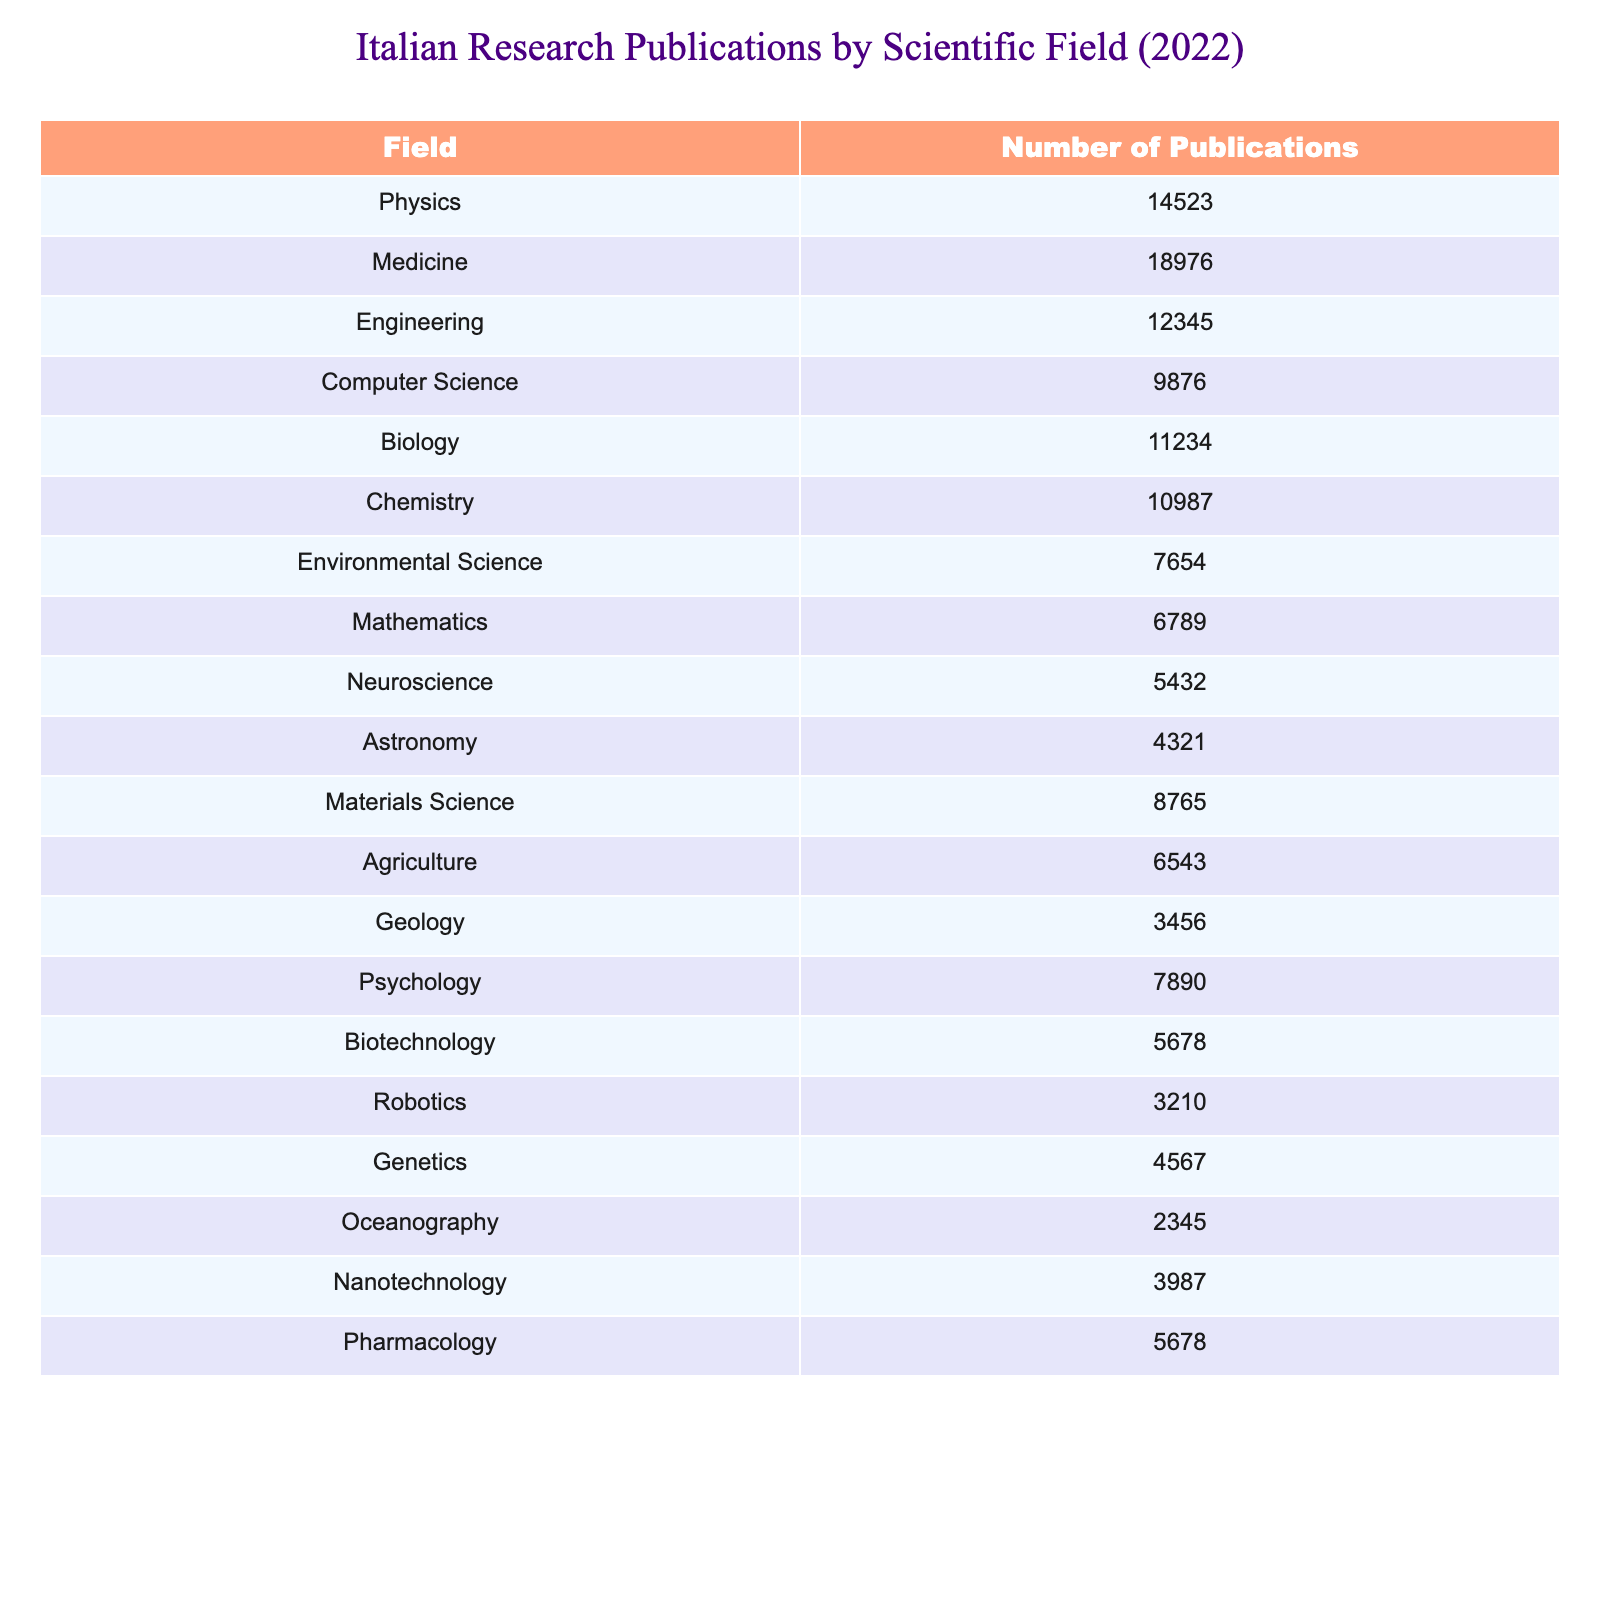What is the field with the highest number of research publications? By examining the table, it's clear that "Medicine" has the highest number of publications at 18976.
Answer: Medicine How many research publications were there in Chemistry? The table indicates that the number of publications in Chemistry is 10987.
Answer: 10987 What is the total number of publications in Physics and Engineering combined? Adding the values from the table, Physics has 14523 and Engineering has 12345, so 14523 + 12345 = 26868.
Answer: 26868 Is the number of publications in Biology greater than in Physics? The table shows that Biology has 11234 publications, which is less than Physics at 14523, so the answer is no.
Answer: No Which two fields have the least number of publications? By reviewing the table, "Oceanography" with 2345 publications and "Robotics" with 3210 publications represent the lowest counts.
Answer: Oceanography and Robotics What is the average number of publications across all fields listed? There are 20 fields, and the total number of publications is the sum of all listed values: 14523 + 18976 + 12345 + 9876 + 11234 + 10987 + 7654 + 6789 + 5432 + 4321 + 8765 + 6543 + 3456 + 7890 + 5678 + 3210 + 4567 + 2345 + 3987 + 5678 = 100,968. Dividing this by 20 gives an average of 5048.4.
Answer: Approximately 5048.4 How much greater is the publication count in Medicine compared to Neuroscience? Medicine has 18976 publications versus Neuroscience's 5432. Calculating the difference yields 18976 - 5432 = 13544.
Answer: 13544 Are there more publications in Environmental Science than in Agriculture? The table shows Environmental Science has 7654 publications and Agriculture has 6543. Since 7654 is greater than 6543, the answer is yes.
Answer: Yes What percentage of the total publications do Computer Science publications represent? The total publications across all fields are 100,968, with Computer Science having 9876. Calculating the percentage: (9876 / 100968) * 100 = 9.76%.
Answer: Approximately 9.76% If we combine the number of publications from Genetics and Biotechnology, how does it compare to the total in Chemistry? Genetics has 4567 and Biotechnology has 5678; their sum is 4567 + 5678 = 10245. Since Chemistry has 10987, we see that 10245 is less than 10987.
Answer: Less than Chemistry What is the difference in publication numbers between the fields of Psychology and Geology? Psychology has 7890 publications and Geology has 3456. The difference is 7890 - 3456 = 4434.
Answer: 4434 